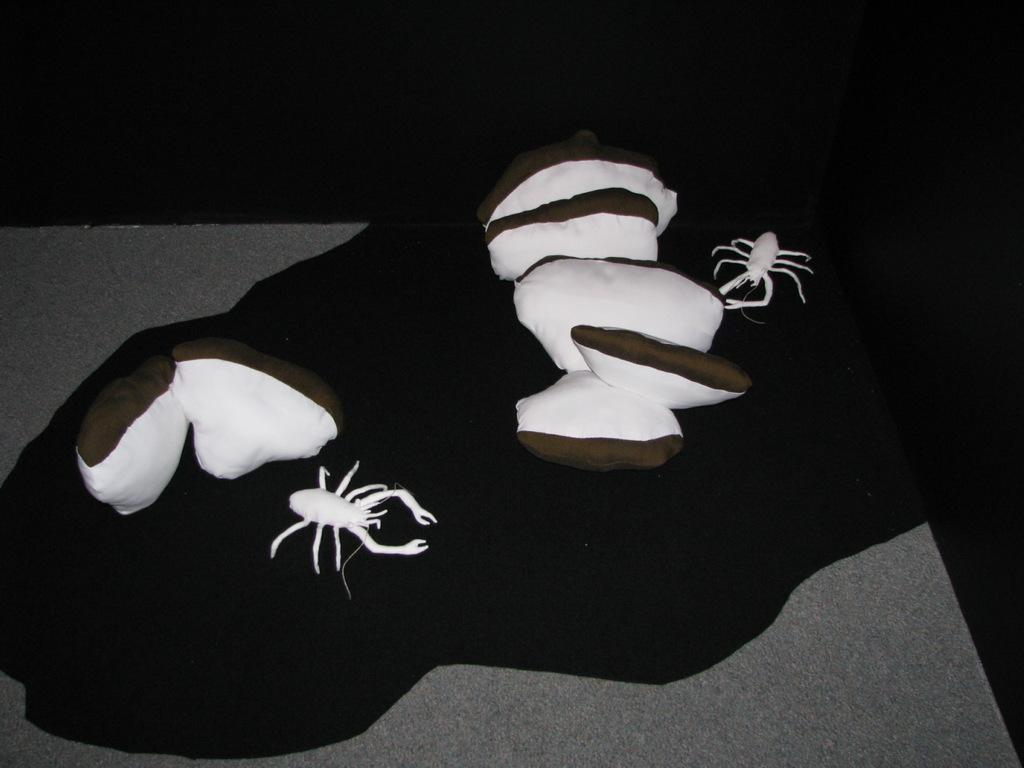What type of animals are in the image? There are crabs in the image. What can be seen on a raised surface in the image? There are objects on a platform in the image. How would you describe the lighting in the image? The background of the image is dark. What type of yam is being used to celebrate the birthday in the image? There is no yam or birthday celebration present in the image; it features crabs and objects on a platform. 